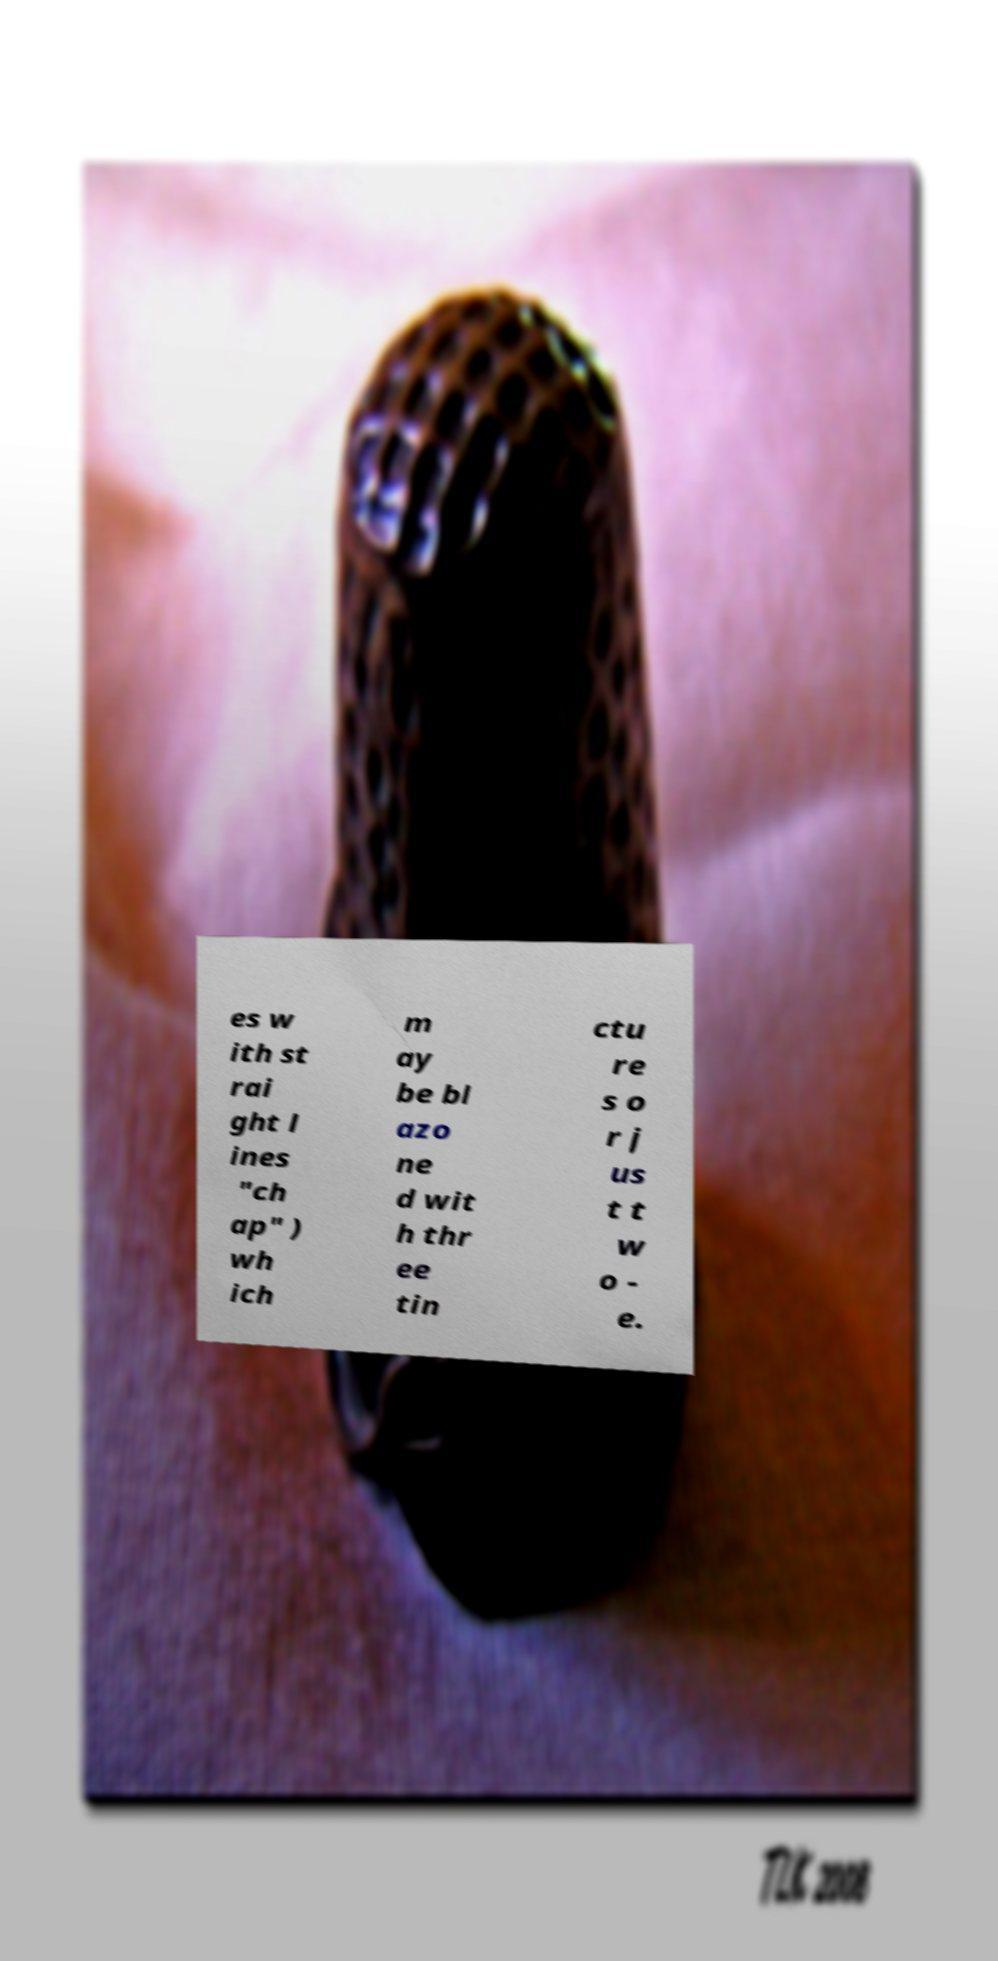What messages or text are displayed in this image? I need them in a readable, typed format. es w ith st rai ght l ines "ch ap" ) wh ich m ay be bl azo ne d wit h thr ee tin ctu re s o r j us t t w o - e. 